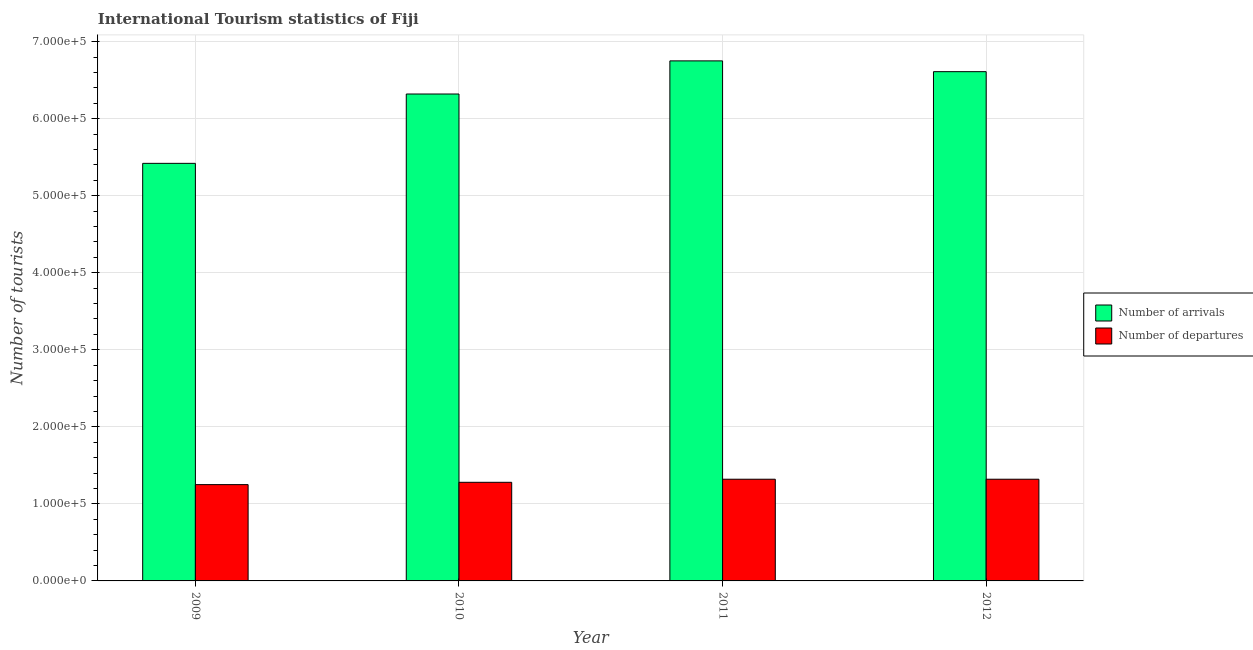How many different coloured bars are there?
Your response must be concise. 2. Are the number of bars per tick equal to the number of legend labels?
Provide a short and direct response. Yes. Are the number of bars on each tick of the X-axis equal?
Your response must be concise. Yes. How many bars are there on the 2nd tick from the left?
Your answer should be very brief. 2. What is the label of the 2nd group of bars from the left?
Make the answer very short. 2010. In how many cases, is the number of bars for a given year not equal to the number of legend labels?
Make the answer very short. 0. What is the number of tourist departures in 2011?
Your answer should be compact. 1.32e+05. Across all years, what is the maximum number of tourist arrivals?
Your response must be concise. 6.75e+05. Across all years, what is the minimum number of tourist departures?
Ensure brevity in your answer.  1.25e+05. In which year was the number of tourist departures maximum?
Keep it short and to the point. 2011. In which year was the number of tourist arrivals minimum?
Offer a terse response. 2009. What is the total number of tourist arrivals in the graph?
Your answer should be very brief. 2.51e+06. What is the difference between the number of tourist departures in 2010 and that in 2012?
Provide a short and direct response. -4000. What is the difference between the number of tourist arrivals in 2012 and the number of tourist departures in 2010?
Your answer should be compact. 2.90e+04. What is the average number of tourist arrivals per year?
Provide a short and direct response. 6.28e+05. In the year 2010, what is the difference between the number of tourist departures and number of tourist arrivals?
Offer a terse response. 0. In how many years, is the number of tourist departures greater than 600000?
Your response must be concise. 0. What is the ratio of the number of tourist arrivals in 2009 to that in 2011?
Keep it short and to the point. 0.8. Is the difference between the number of tourist arrivals in 2009 and 2011 greater than the difference between the number of tourist departures in 2009 and 2011?
Your response must be concise. No. What is the difference between the highest and the second highest number of tourist departures?
Offer a terse response. 0. What is the difference between the highest and the lowest number of tourist arrivals?
Your response must be concise. 1.33e+05. In how many years, is the number of tourist arrivals greater than the average number of tourist arrivals taken over all years?
Your answer should be very brief. 3. Is the sum of the number of tourist departures in 2009 and 2012 greater than the maximum number of tourist arrivals across all years?
Give a very brief answer. Yes. What does the 1st bar from the left in 2009 represents?
Ensure brevity in your answer.  Number of arrivals. What does the 2nd bar from the right in 2012 represents?
Your answer should be very brief. Number of arrivals. How many bars are there?
Keep it short and to the point. 8. Are all the bars in the graph horizontal?
Offer a terse response. No. Are the values on the major ticks of Y-axis written in scientific E-notation?
Ensure brevity in your answer.  Yes. Where does the legend appear in the graph?
Provide a succinct answer. Center right. What is the title of the graph?
Your answer should be compact. International Tourism statistics of Fiji. What is the label or title of the Y-axis?
Provide a short and direct response. Number of tourists. What is the Number of tourists of Number of arrivals in 2009?
Your answer should be compact. 5.42e+05. What is the Number of tourists in Number of departures in 2009?
Give a very brief answer. 1.25e+05. What is the Number of tourists in Number of arrivals in 2010?
Keep it short and to the point. 6.32e+05. What is the Number of tourists in Number of departures in 2010?
Give a very brief answer. 1.28e+05. What is the Number of tourists of Number of arrivals in 2011?
Your answer should be very brief. 6.75e+05. What is the Number of tourists in Number of departures in 2011?
Offer a terse response. 1.32e+05. What is the Number of tourists of Number of arrivals in 2012?
Offer a terse response. 6.61e+05. What is the Number of tourists in Number of departures in 2012?
Your answer should be compact. 1.32e+05. Across all years, what is the maximum Number of tourists of Number of arrivals?
Offer a terse response. 6.75e+05. Across all years, what is the maximum Number of tourists of Number of departures?
Keep it short and to the point. 1.32e+05. Across all years, what is the minimum Number of tourists in Number of arrivals?
Provide a succinct answer. 5.42e+05. Across all years, what is the minimum Number of tourists in Number of departures?
Offer a very short reply. 1.25e+05. What is the total Number of tourists of Number of arrivals in the graph?
Make the answer very short. 2.51e+06. What is the total Number of tourists in Number of departures in the graph?
Provide a succinct answer. 5.17e+05. What is the difference between the Number of tourists of Number of departures in 2009 and that in 2010?
Give a very brief answer. -3000. What is the difference between the Number of tourists in Number of arrivals in 2009 and that in 2011?
Offer a very short reply. -1.33e+05. What is the difference between the Number of tourists in Number of departures in 2009 and that in 2011?
Make the answer very short. -7000. What is the difference between the Number of tourists in Number of arrivals in 2009 and that in 2012?
Offer a terse response. -1.19e+05. What is the difference between the Number of tourists in Number of departures in 2009 and that in 2012?
Keep it short and to the point. -7000. What is the difference between the Number of tourists in Number of arrivals in 2010 and that in 2011?
Give a very brief answer. -4.30e+04. What is the difference between the Number of tourists of Number of departures in 2010 and that in 2011?
Provide a succinct answer. -4000. What is the difference between the Number of tourists of Number of arrivals in 2010 and that in 2012?
Ensure brevity in your answer.  -2.90e+04. What is the difference between the Number of tourists in Number of departures in 2010 and that in 2012?
Provide a succinct answer. -4000. What is the difference between the Number of tourists of Number of arrivals in 2011 and that in 2012?
Make the answer very short. 1.40e+04. What is the difference between the Number of tourists of Number of arrivals in 2009 and the Number of tourists of Number of departures in 2010?
Make the answer very short. 4.14e+05. What is the difference between the Number of tourists of Number of arrivals in 2009 and the Number of tourists of Number of departures in 2011?
Offer a very short reply. 4.10e+05. What is the difference between the Number of tourists of Number of arrivals in 2009 and the Number of tourists of Number of departures in 2012?
Offer a terse response. 4.10e+05. What is the difference between the Number of tourists in Number of arrivals in 2010 and the Number of tourists in Number of departures in 2011?
Keep it short and to the point. 5.00e+05. What is the difference between the Number of tourists in Number of arrivals in 2010 and the Number of tourists in Number of departures in 2012?
Make the answer very short. 5.00e+05. What is the difference between the Number of tourists of Number of arrivals in 2011 and the Number of tourists of Number of departures in 2012?
Make the answer very short. 5.43e+05. What is the average Number of tourists in Number of arrivals per year?
Keep it short and to the point. 6.28e+05. What is the average Number of tourists in Number of departures per year?
Your answer should be compact. 1.29e+05. In the year 2009, what is the difference between the Number of tourists in Number of arrivals and Number of tourists in Number of departures?
Offer a terse response. 4.17e+05. In the year 2010, what is the difference between the Number of tourists of Number of arrivals and Number of tourists of Number of departures?
Provide a succinct answer. 5.04e+05. In the year 2011, what is the difference between the Number of tourists of Number of arrivals and Number of tourists of Number of departures?
Give a very brief answer. 5.43e+05. In the year 2012, what is the difference between the Number of tourists of Number of arrivals and Number of tourists of Number of departures?
Your answer should be very brief. 5.29e+05. What is the ratio of the Number of tourists in Number of arrivals in 2009 to that in 2010?
Provide a short and direct response. 0.86. What is the ratio of the Number of tourists in Number of departures in 2009 to that in 2010?
Provide a succinct answer. 0.98. What is the ratio of the Number of tourists of Number of arrivals in 2009 to that in 2011?
Provide a short and direct response. 0.8. What is the ratio of the Number of tourists in Number of departures in 2009 to that in 2011?
Give a very brief answer. 0.95. What is the ratio of the Number of tourists in Number of arrivals in 2009 to that in 2012?
Provide a succinct answer. 0.82. What is the ratio of the Number of tourists in Number of departures in 2009 to that in 2012?
Your answer should be compact. 0.95. What is the ratio of the Number of tourists of Number of arrivals in 2010 to that in 2011?
Provide a succinct answer. 0.94. What is the ratio of the Number of tourists in Number of departures in 2010 to that in 2011?
Your response must be concise. 0.97. What is the ratio of the Number of tourists of Number of arrivals in 2010 to that in 2012?
Offer a terse response. 0.96. What is the ratio of the Number of tourists in Number of departures in 2010 to that in 2012?
Provide a succinct answer. 0.97. What is the ratio of the Number of tourists of Number of arrivals in 2011 to that in 2012?
Provide a short and direct response. 1.02. What is the ratio of the Number of tourists in Number of departures in 2011 to that in 2012?
Make the answer very short. 1. What is the difference between the highest and the second highest Number of tourists of Number of arrivals?
Keep it short and to the point. 1.40e+04. What is the difference between the highest and the lowest Number of tourists in Number of arrivals?
Provide a short and direct response. 1.33e+05. What is the difference between the highest and the lowest Number of tourists of Number of departures?
Offer a very short reply. 7000. 